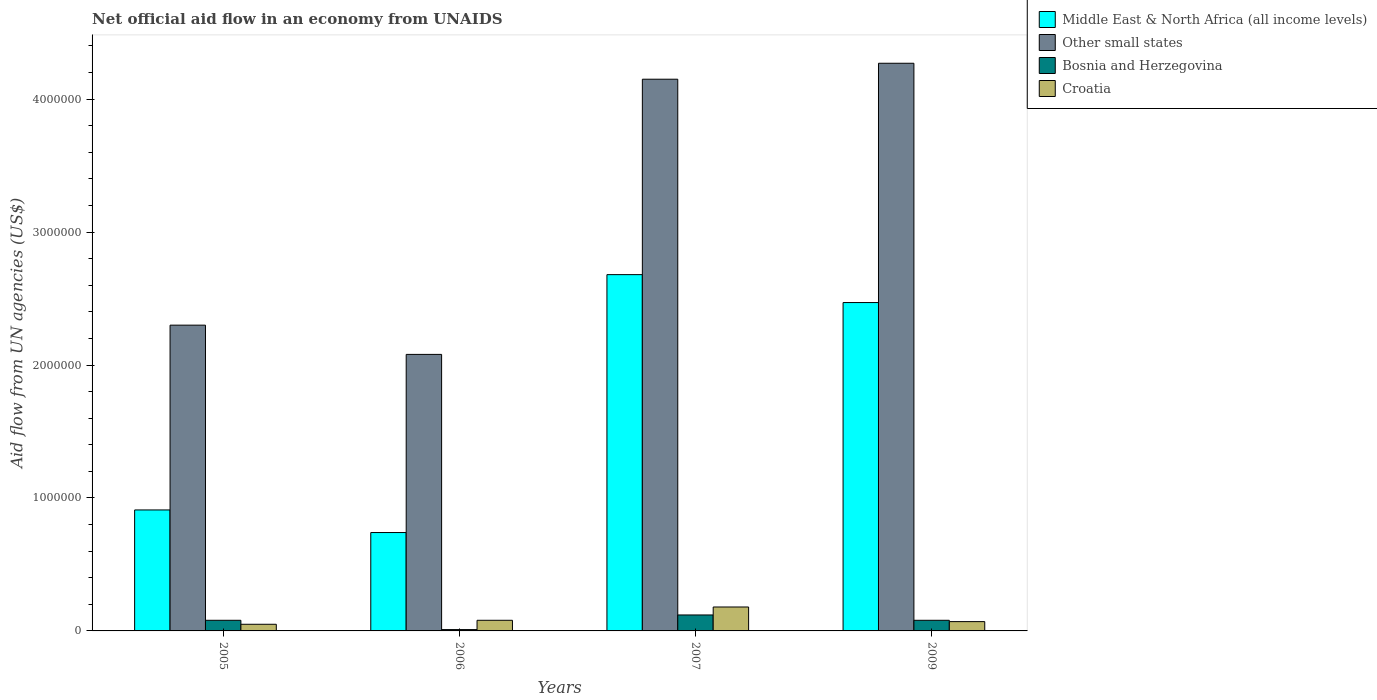How many groups of bars are there?
Provide a succinct answer. 4. Are the number of bars per tick equal to the number of legend labels?
Keep it short and to the point. Yes. Are the number of bars on each tick of the X-axis equal?
Keep it short and to the point. Yes. How many bars are there on the 4th tick from the left?
Your answer should be compact. 4. In how many cases, is the number of bars for a given year not equal to the number of legend labels?
Make the answer very short. 0. What is the net official aid flow in Other small states in 2006?
Your answer should be very brief. 2.08e+06. Across all years, what is the maximum net official aid flow in Bosnia and Herzegovina?
Ensure brevity in your answer.  1.20e+05. Across all years, what is the minimum net official aid flow in Croatia?
Your response must be concise. 5.00e+04. In which year was the net official aid flow in Bosnia and Herzegovina maximum?
Make the answer very short. 2007. What is the difference between the net official aid flow in Middle East & North Africa (all income levels) in 2009 and the net official aid flow in Bosnia and Herzegovina in 2006?
Ensure brevity in your answer.  2.46e+06. What is the average net official aid flow in Middle East & North Africa (all income levels) per year?
Keep it short and to the point. 1.70e+06. In the year 2006, what is the difference between the net official aid flow in Middle East & North Africa (all income levels) and net official aid flow in Other small states?
Your answer should be compact. -1.34e+06. In how many years, is the net official aid flow in Croatia greater than 2800000 US$?
Ensure brevity in your answer.  0. What is the ratio of the net official aid flow in Other small states in 2005 to that in 2007?
Make the answer very short. 0.55. What is the difference between the highest and the lowest net official aid flow in Middle East & North Africa (all income levels)?
Ensure brevity in your answer.  1.94e+06. In how many years, is the net official aid flow in Croatia greater than the average net official aid flow in Croatia taken over all years?
Keep it short and to the point. 1. What does the 4th bar from the left in 2009 represents?
Provide a succinct answer. Croatia. What does the 2nd bar from the right in 2006 represents?
Provide a succinct answer. Bosnia and Herzegovina. How many years are there in the graph?
Keep it short and to the point. 4. Does the graph contain grids?
Ensure brevity in your answer.  No. Where does the legend appear in the graph?
Offer a very short reply. Top right. How are the legend labels stacked?
Your answer should be compact. Vertical. What is the title of the graph?
Your response must be concise. Net official aid flow in an economy from UNAIDS. Does "Uzbekistan" appear as one of the legend labels in the graph?
Offer a terse response. No. What is the label or title of the X-axis?
Offer a terse response. Years. What is the label or title of the Y-axis?
Offer a terse response. Aid flow from UN agencies (US$). What is the Aid flow from UN agencies (US$) of Middle East & North Africa (all income levels) in 2005?
Offer a terse response. 9.10e+05. What is the Aid flow from UN agencies (US$) in Other small states in 2005?
Offer a terse response. 2.30e+06. What is the Aid flow from UN agencies (US$) in Bosnia and Herzegovina in 2005?
Your response must be concise. 8.00e+04. What is the Aid flow from UN agencies (US$) of Middle East & North Africa (all income levels) in 2006?
Your answer should be very brief. 7.40e+05. What is the Aid flow from UN agencies (US$) in Other small states in 2006?
Offer a terse response. 2.08e+06. What is the Aid flow from UN agencies (US$) in Middle East & North Africa (all income levels) in 2007?
Offer a terse response. 2.68e+06. What is the Aid flow from UN agencies (US$) of Other small states in 2007?
Offer a terse response. 4.15e+06. What is the Aid flow from UN agencies (US$) of Middle East & North Africa (all income levels) in 2009?
Offer a very short reply. 2.47e+06. What is the Aid flow from UN agencies (US$) of Other small states in 2009?
Provide a short and direct response. 4.27e+06. What is the Aid flow from UN agencies (US$) in Bosnia and Herzegovina in 2009?
Make the answer very short. 8.00e+04. Across all years, what is the maximum Aid flow from UN agencies (US$) of Middle East & North Africa (all income levels)?
Your answer should be compact. 2.68e+06. Across all years, what is the maximum Aid flow from UN agencies (US$) of Other small states?
Make the answer very short. 4.27e+06. Across all years, what is the minimum Aid flow from UN agencies (US$) of Middle East & North Africa (all income levels)?
Give a very brief answer. 7.40e+05. Across all years, what is the minimum Aid flow from UN agencies (US$) in Other small states?
Ensure brevity in your answer.  2.08e+06. Across all years, what is the minimum Aid flow from UN agencies (US$) in Croatia?
Give a very brief answer. 5.00e+04. What is the total Aid flow from UN agencies (US$) of Middle East & North Africa (all income levels) in the graph?
Offer a terse response. 6.80e+06. What is the total Aid flow from UN agencies (US$) of Other small states in the graph?
Give a very brief answer. 1.28e+07. What is the difference between the Aid flow from UN agencies (US$) of Middle East & North Africa (all income levels) in 2005 and that in 2006?
Give a very brief answer. 1.70e+05. What is the difference between the Aid flow from UN agencies (US$) of Other small states in 2005 and that in 2006?
Ensure brevity in your answer.  2.20e+05. What is the difference between the Aid flow from UN agencies (US$) in Bosnia and Herzegovina in 2005 and that in 2006?
Provide a short and direct response. 7.00e+04. What is the difference between the Aid flow from UN agencies (US$) in Croatia in 2005 and that in 2006?
Ensure brevity in your answer.  -3.00e+04. What is the difference between the Aid flow from UN agencies (US$) in Middle East & North Africa (all income levels) in 2005 and that in 2007?
Ensure brevity in your answer.  -1.77e+06. What is the difference between the Aid flow from UN agencies (US$) in Other small states in 2005 and that in 2007?
Offer a very short reply. -1.85e+06. What is the difference between the Aid flow from UN agencies (US$) in Middle East & North Africa (all income levels) in 2005 and that in 2009?
Give a very brief answer. -1.56e+06. What is the difference between the Aid flow from UN agencies (US$) of Other small states in 2005 and that in 2009?
Your response must be concise. -1.97e+06. What is the difference between the Aid flow from UN agencies (US$) in Middle East & North Africa (all income levels) in 2006 and that in 2007?
Your response must be concise. -1.94e+06. What is the difference between the Aid flow from UN agencies (US$) of Other small states in 2006 and that in 2007?
Keep it short and to the point. -2.07e+06. What is the difference between the Aid flow from UN agencies (US$) in Middle East & North Africa (all income levels) in 2006 and that in 2009?
Your response must be concise. -1.73e+06. What is the difference between the Aid flow from UN agencies (US$) of Other small states in 2006 and that in 2009?
Your answer should be very brief. -2.19e+06. What is the difference between the Aid flow from UN agencies (US$) of Bosnia and Herzegovina in 2006 and that in 2009?
Give a very brief answer. -7.00e+04. What is the difference between the Aid flow from UN agencies (US$) of Other small states in 2007 and that in 2009?
Give a very brief answer. -1.20e+05. What is the difference between the Aid flow from UN agencies (US$) in Middle East & North Africa (all income levels) in 2005 and the Aid flow from UN agencies (US$) in Other small states in 2006?
Keep it short and to the point. -1.17e+06. What is the difference between the Aid flow from UN agencies (US$) in Middle East & North Africa (all income levels) in 2005 and the Aid flow from UN agencies (US$) in Croatia in 2006?
Give a very brief answer. 8.30e+05. What is the difference between the Aid flow from UN agencies (US$) of Other small states in 2005 and the Aid flow from UN agencies (US$) of Bosnia and Herzegovina in 2006?
Provide a short and direct response. 2.29e+06. What is the difference between the Aid flow from UN agencies (US$) of Other small states in 2005 and the Aid flow from UN agencies (US$) of Croatia in 2006?
Your answer should be compact. 2.22e+06. What is the difference between the Aid flow from UN agencies (US$) in Bosnia and Herzegovina in 2005 and the Aid flow from UN agencies (US$) in Croatia in 2006?
Your answer should be very brief. 0. What is the difference between the Aid flow from UN agencies (US$) in Middle East & North Africa (all income levels) in 2005 and the Aid flow from UN agencies (US$) in Other small states in 2007?
Offer a very short reply. -3.24e+06. What is the difference between the Aid flow from UN agencies (US$) of Middle East & North Africa (all income levels) in 2005 and the Aid flow from UN agencies (US$) of Bosnia and Herzegovina in 2007?
Your answer should be compact. 7.90e+05. What is the difference between the Aid flow from UN agencies (US$) of Middle East & North Africa (all income levels) in 2005 and the Aid flow from UN agencies (US$) of Croatia in 2007?
Give a very brief answer. 7.30e+05. What is the difference between the Aid flow from UN agencies (US$) of Other small states in 2005 and the Aid flow from UN agencies (US$) of Bosnia and Herzegovina in 2007?
Your answer should be compact. 2.18e+06. What is the difference between the Aid flow from UN agencies (US$) of Other small states in 2005 and the Aid flow from UN agencies (US$) of Croatia in 2007?
Ensure brevity in your answer.  2.12e+06. What is the difference between the Aid flow from UN agencies (US$) of Bosnia and Herzegovina in 2005 and the Aid flow from UN agencies (US$) of Croatia in 2007?
Your answer should be very brief. -1.00e+05. What is the difference between the Aid flow from UN agencies (US$) in Middle East & North Africa (all income levels) in 2005 and the Aid flow from UN agencies (US$) in Other small states in 2009?
Keep it short and to the point. -3.36e+06. What is the difference between the Aid flow from UN agencies (US$) in Middle East & North Africa (all income levels) in 2005 and the Aid flow from UN agencies (US$) in Bosnia and Herzegovina in 2009?
Keep it short and to the point. 8.30e+05. What is the difference between the Aid flow from UN agencies (US$) of Middle East & North Africa (all income levels) in 2005 and the Aid flow from UN agencies (US$) of Croatia in 2009?
Offer a terse response. 8.40e+05. What is the difference between the Aid flow from UN agencies (US$) of Other small states in 2005 and the Aid flow from UN agencies (US$) of Bosnia and Herzegovina in 2009?
Your response must be concise. 2.22e+06. What is the difference between the Aid flow from UN agencies (US$) of Other small states in 2005 and the Aid flow from UN agencies (US$) of Croatia in 2009?
Ensure brevity in your answer.  2.23e+06. What is the difference between the Aid flow from UN agencies (US$) of Middle East & North Africa (all income levels) in 2006 and the Aid flow from UN agencies (US$) of Other small states in 2007?
Provide a succinct answer. -3.41e+06. What is the difference between the Aid flow from UN agencies (US$) in Middle East & North Africa (all income levels) in 2006 and the Aid flow from UN agencies (US$) in Bosnia and Herzegovina in 2007?
Your answer should be very brief. 6.20e+05. What is the difference between the Aid flow from UN agencies (US$) in Middle East & North Africa (all income levels) in 2006 and the Aid flow from UN agencies (US$) in Croatia in 2007?
Your answer should be compact. 5.60e+05. What is the difference between the Aid flow from UN agencies (US$) in Other small states in 2006 and the Aid flow from UN agencies (US$) in Bosnia and Herzegovina in 2007?
Make the answer very short. 1.96e+06. What is the difference between the Aid flow from UN agencies (US$) of Other small states in 2006 and the Aid flow from UN agencies (US$) of Croatia in 2007?
Your answer should be compact. 1.90e+06. What is the difference between the Aid flow from UN agencies (US$) of Middle East & North Africa (all income levels) in 2006 and the Aid flow from UN agencies (US$) of Other small states in 2009?
Your response must be concise. -3.53e+06. What is the difference between the Aid flow from UN agencies (US$) of Middle East & North Africa (all income levels) in 2006 and the Aid flow from UN agencies (US$) of Bosnia and Herzegovina in 2009?
Make the answer very short. 6.60e+05. What is the difference between the Aid flow from UN agencies (US$) in Middle East & North Africa (all income levels) in 2006 and the Aid flow from UN agencies (US$) in Croatia in 2009?
Provide a short and direct response. 6.70e+05. What is the difference between the Aid flow from UN agencies (US$) in Other small states in 2006 and the Aid flow from UN agencies (US$) in Bosnia and Herzegovina in 2009?
Offer a very short reply. 2.00e+06. What is the difference between the Aid flow from UN agencies (US$) in Other small states in 2006 and the Aid flow from UN agencies (US$) in Croatia in 2009?
Offer a very short reply. 2.01e+06. What is the difference between the Aid flow from UN agencies (US$) in Middle East & North Africa (all income levels) in 2007 and the Aid flow from UN agencies (US$) in Other small states in 2009?
Give a very brief answer. -1.59e+06. What is the difference between the Aid flow from UN agencies (US$) of Middle East & North Africa (all income levels) in 2007 and the Aid flow from UN agencies (US$) of Bosnia and Herzegovina in 2009?
Offer a terse response. 2.60e+06. What is the difference between the Aid flow from UN agencies (US$) in Middle East & North Africa (all income levels) in 2007 and the Aid flow from UN agencies (US$) in Croatia in 2009?
Keep it short and to the point. 2.61e+06. What is the difference between the Aid flow from UN agencies (US$) of Other small states in 2007 and the Aid flow from UN agencies (US$) of Bosnia and Herzegovina in 2009?
Ensure brevity in your answer.  4.07e+06. What is the difference between the Aid flow from UN agencies (US$) in Other small states in 2007 and the Aid flow from UN agencies (US$) in Croatia in 2009?
Your answer should be compact. 4.08e+06. What is the difference between the Aid flow from UN agencies (US$) of Bosnia and Herzegovina in 2007 and the Aid flow from UN agencies (US$) of Croatia in 2009?
Make the answer very short. 5.00e+04. What is the average Aid flow from UN agencies (US$) of Middle East & North Africa (all income levels) per year?
Make the answer very short. 1.70e+06. What is the average Aid flow from UN agencies (US$) of Other small states per year?
Offer a very short reply. 3.20e+06. What is the average Aid flow from UN agencies (US$) of Bosnia and Herzegovina per year?
Provide a short and direct response. 7.25e+04. What is the average Aid flow from UN agencies (US$) of Croatia per year?
Offer a very short reply. 9.50e+04. In the year 2005, what is the difference between the Aid flow from UN agencies (US$) in Middle East & North Africa (all income levels) and Aid flow from UN agencies (US$) in Other small states?
Offer a terse response. -1.39e+06. In the year 2005, what is the difference between the Aid flow from UN agencies (US$) in Middle East & North Africa (all income levels) and Aid flow from UN agencies (US$) in Bosnia and Herzegovina?
Ensure brevity in your answer.  8.30e+05. In the year 2005, what is the difference between the Aid flow from UN agencies (US$) of Middle East & North Africa (all income levels) and Aid flow from UN agencies (US$) of Croatia?
Make the answer very short. 8.60e+05. In the year 2005, what is the difference between the Aid flow from UN agencies (US$) in Other small states and Aid flow from UN agencies (US$) in Bosnia and Herzegovina?
Give a very brief answer. 2.22e+06. In the year 2005, what is the difference between the Aid flow from UN agencies (US$) of Other small states and Aid flow from UN agencies (US$) of Croatia?
Offer a very short reply. 2.25e+06. In the year 2006, what is the difference between the Aid flow from UN agencies (US$) in Middle East & North Africa (all income levels) and Aid flow from UN agencies (US$) in Other small states?
Your answer should be compact. -1.34e+06. In the year 2006, what is the difference between the Aid flow from UN agencies (US$) of Middle East & North Africa (all income levels) and Aid flow from UN agencies (US$) of Bosnia and Herzegovina?
Give a very brief answer. 7.30e+05. In the year 2006, what is the difference between the Aid flow from UN agencies (US$) of Middle East & North Africa (all income levels) and Aid flow from UN agencies (US$) of Croatia?
Your response must be concise. 6.60e+05. In the year 2006, what is the difference between the Aid flow from UN agencies (US$) of Other small states and Aid flow from UN agencies (US$) of Bosnia and Herzegovina?
Keep it short and to the point. 2.07e+06. In the year 2006, what is the difference between the Aid flow from UN agencies (US$) in Bosnia and Herzegovina and Aid flow from UN agencies (US$) in Croatia?
Provide a succinct answer. -7.00e+04. In the year 2007, what is the difference between the Aid flow from UN agencies (US$) of Middle East & North Africa (all income levels) and Aid flow from UN agencies (US$) of Other small states?
Make the answer very short. -1.47e+06. In the year 2007, what is the difference between the Aid flow from UN agencies (US$) in Middle East & North Africa (all income levels) and Aid flow from UN agencies (US$) in Bosnia and Herzegovina?
Provide a succinct answer. 2.56e+06. In the year 2007, what is the difference between the Aid flow from UN agencies (US$) of Middle East & North Africa (all income levels) and Aid flow from UN agencies (US$) of Croatia?
Offer a very short reply. 2.50e+06. In the year 2007, what is the difference between the Aid flow from UN agencies (US$) in Other small states and Aid flow from UN agencies (US$) in Bosnia and Herzegovina?
Your answer should be very brief. 4.03e+06. In the year 2007, what is the difference between the Aid flow from UN agencies (US$) in Other small states and Aid flow from UN agencies (US$) in Croatia?
Provide a short and direct response. 3.97e+06. In the year 2007, what is the difference between the Aid flow from UN agencies (US$) of Bosnia and Herzegovina and Aid flow from UN agencies (US$) of Croatia?
Give a very brief answer. -6.00e+04. In the year 2009, what is the difference between the Aid flow from UN agencies (US$) in Middle East & North Africa (all income levels) and Aid flow from UN agencies (US$) in Other small states?
Keep it short and to the point. -1.80e+06. In the year 2009, what is the difference between the Aid flow from UN agencies (US$) of Middle East & North Africa (all income levels) and Aid flow from UN agencies (US$) of Bosnia and Herzegovina?
Provide a short and direct response. 2.39e+06. In the year 2009, what is the difference between the Aid flow from UN agencies (US$) of Middle East & North Africa (all income levels) and Aid flow from UN agencies (US$) of Croatia?
Provide a short and direct response. 2.40e+06. In the year 2009, what is the difference between the Aid flow from UN agencies (US$) in Other small states and Aid flow from UN agencies (US$) in Bosnia and Herzegovina?
Keep it short and to the point. 4.19e+06. In the year 2009, what is the difference between the Aid flow from UN agencies (US$) of Other small states and Aid flow from UN agencies (US$) of Croatia?
Offer a very short reply. 4.20e+06. What is the ratio of the Aid flow from UN agencies (US$) in Middle East & North Africa (all income levels) in 2005 to that in 2006?
Make the answer very short. 1.23. What is the ratio of the Aid flow from UN agencies (US$) in Other small states in 2005 to that in 2006?
Your answer should be compact. 1.11. What is the ratio of the Aid flow from UN agencies (US$) in Bosnia and Herzegovina in 2005 to that in 2006?
Provide a short and direct response. 8. What is the ratio of the Aid flow from UN agencies (US$) in Croatia in 2005 to that in 2006?
Offer a very short reply. 0.62. What is the ratio of the Aid flow from UN agencies (US$) in Middle East & North Africa (all income levels) in 2005 to that in 2007?
Provide a succinct answer. 0.34. What is the ratio of the Aid flow from UN agencies (US$) in Other small states in 2005 to that in 2007?
Your answer should be very brief. 0.55. What is the ratio of the Aid flow from UN agencies (US$) in Croatia in 2005 to that in 2007?
Offer a terse response. 0.28. What is the ratio of the Aid flow from UN agencies (US$) of Middle East & North Africa (all income levels) in 2005 to that in 2009?
Provide a short and direct response. 0.37. What is the ratio of the Aid flow from UN agencies (US$) of Other small states in 2005 to that in 2009?
Your answer should be very brief. 0.54. What is the ratio of the Aid flow from UN agencies (US$) in Croatia in 2005 to that in 2009?
Offer a very short reply. 0.71. What is the ratio of the Aid flow from UN agencies (US$) of Middle East & North Africa (all income levels) in 2006 to that in 2007?
Make the answer very short. 0.28. What is the ratio of the Aid flow from UN agencies (US$) of Other small states in 2006 to that in 2007?
Offer a terse response. 0.5. What is the ratio of the Aid flow from UN agencies (US$) of Bosnia and Herzegovina in 2006 to that in 2007?
Make the answer very short. 0.08. What is the ratio of the Aid flow from UN agencies (US$) of Croatia in 2006 to that in 2007?
Provide a succinct answer. 0.44. What is the ratio of the Aid flow from UN agencies (US$) of Middle East & North Africa (all income levels) in 2006 to that in 2009?
Keep it short and to the point. 0.3. What is the ratio of the Aid flow from UN agencies (US$) of Other small states in 2006 to that in 2009?
Offer a terse response. 0.49. What is the ratio of the Aid flow from UN agencies (US$) of Croatia in 2006 to that in 2009?
Your answer should be very brief. 1.14. What is the ratio of the Aid flow from UN agencies (US$) of Middle East & North Africa (all income levels) in 2007 to that in 2009?
Give a very brief answer. 1.08. What is the ratio of the Aid flow from UN agencies (US$) of Other small states in 2007 to that in 2009?
Your answer should be compact. 0.97. What is the ratio of the Aid flow from UN agencies (US$) in Croatia in 2007 to that in 2009?
Ensure brevity in your answer.  2.57. What is the difference between the highest and the second highest Aid flow from UN agencies (US$) of Middle East & North Africa (all income levels)?
Keep it short and to the point. 2.10e+05. What is the difference between the highest and the second highest Aid flow from UN agencies (US$) of Other small states?
Offer a terse response. 1.20e+05. What is the difference between the highest and the second highest Aid flow from UN agencies (US$) of Bosnia and Herzegovina?
Your response must be concise. 4.00e+04. What is the difference between the highest and the second highest Aid flow from UN agencies (US$) in Croatia?
Offer a terse response. 1.00e+05. What is the difference between the highest and the lowest Aid flow from UN agencies (US$) of Middle East & North Africa (all income levels)?
Your answer should be compact. 1.94e+06. What is the difference between the highest and the lowest Aid flow from UN agencies (US$) of Other small states?
Your answer should be compact. 2.19e+06. What is the difference between the highest and the lowest Aid flow from UN agencies (US$) in Bosnia and Herzegovina?
Offer a very short reply. 1.10e+05. What is the difference between the highest and the lowest Aid flow from UN agencies (US$) in Croatia?
Provide a short and direct response. 1.30e+05. 